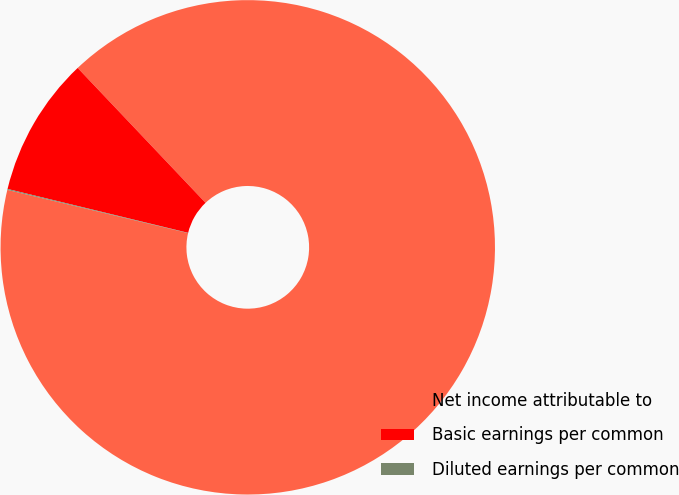Convert chart to OTSL. <chart><loc_0><loc_0><loc_500><loc_500><pie_chart><fcel>Net income attributable to<fcel>Basic earnings per common<fcel>Diluted earnings per common<nl><fcel>90.81%<fcel>9.13%<fcel>0.06%<nl></chart> 